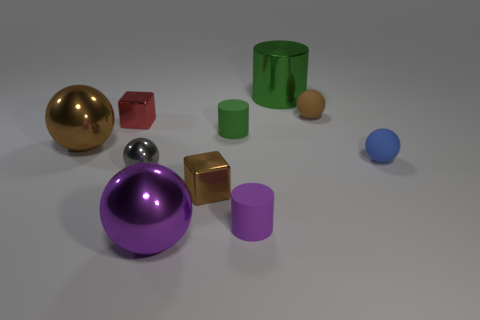Subtract all purple cylinders. How many cylinders are left? 2 Subtract all brown balls. How many green cylinders are left? 2 Subtract 3 balls. How many balls are left? 2 Subtract all purple spheres. How many spheres are left? 4 Subtract 0 gray blocks. How many objects are left? 10 Subtract all cubes. How many objects are left? 8 Subtract all yellow cylinders. Subtract all brown cubes. How many cylinders are left? 3 Subtract all big red cylinders. Subtract all metal cylinders. How many objects are left? 9 Add 4 purple balls. How many purple balls are left? 5 Add 9 tiny brown cubes. How many tiny brown cubes exist? 10 